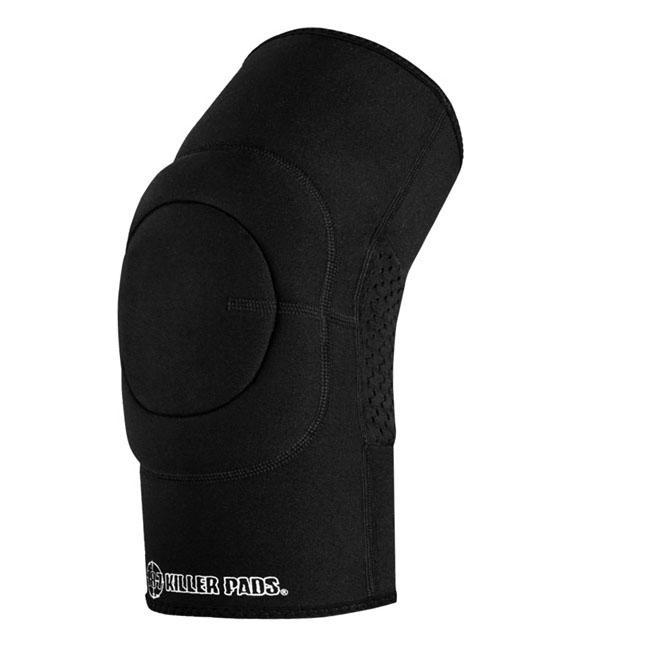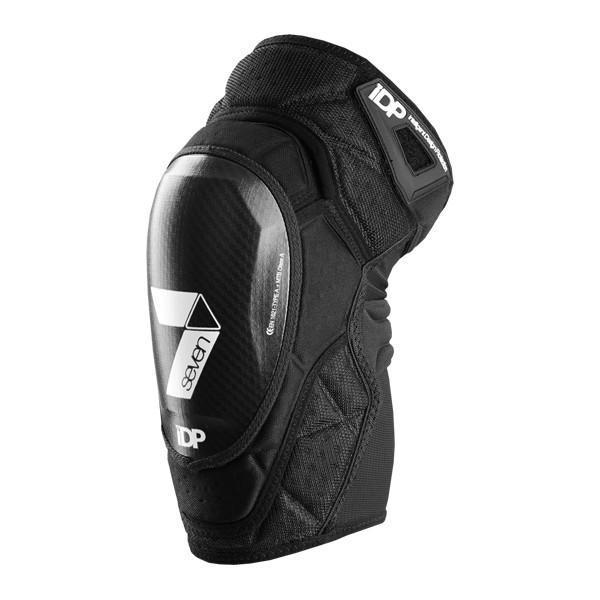The first image is the image on the left, the second image is the image on the right. Evaluate the accuracy of this statement regarding the images: "The only colors on the knee pads are black and white.". Is it true? Answer yes or no. Yes. The first image is the image on the left, the second image is the image on the right. For the images displayed, is the sentence "The pads are facing left in both images." factually correct? Answer yes or no. Yes. 